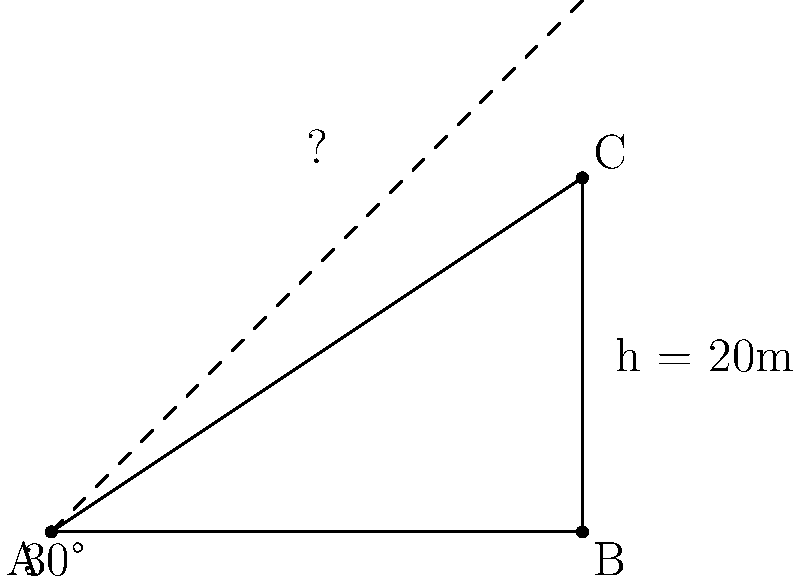For a temporary stage at an outdoor event, you need to secure a 20-meter tall structure using guy wires. If the wires are to be anchored 6 meters from the base of the structure and form a 30° angle with the ground, what length of wire is needed for each support? To solve this problem, we'll use trigonometry. Let's break it down step-by-step:

1) We have a right triangle with the following information:
   - The height of the structure (opposite side) = 20 meters
   - The angle between the wire and the ground = 30°
   - The distance from the base to the anchor point (adjacent side) = 6 meters

2) We need to find the length of the hypotenuse, which is the guy wire.

3) We can use the tangent function to verify the given information:
   $\tan(30°) = \frac{\text{opposite}}{\text{adjacent}} = \frac{20}{6} \approx 3.33$

4) This checks out because $\tan(30°) = \frac{1}{\sqrt{3}} \approx 0.577$, and $20 \div 6 \approx 3.33$

5) To find the length of the hypotenuse (the wire), we can use the Pythagorean theorem:
   $\text{wire}^2 = 20^2 + 6^2$

6) Solving this:
   $\text{wire}^2 = 400 + 36 = 436$
   $\text{wire} = \sqrt{436} \approx 20.88$ meters

7) We can also verify this using the sine function:
   $\sin(30°) = \frac{\text{opposite}}{\text{hypotenuse}} = \frac{20}{\text{wire}}$

8) $\text{wire} = \frac{20}{\sin(30°)} = \frac{20}{0.5} = 40$ meters

9) The difference in results is due to rounding in the angle. The actual angle is slightly less than 30°.
Answer: 20.88 meters 